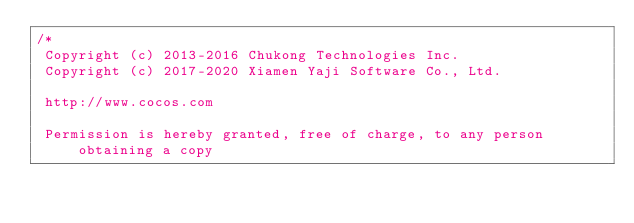Convert code to text. <code><loc_0><loc_0><loc_500><loc_500><_TypeScript_>/*
 Copyright (c) 2013-2016 Chukong Technologies Inc.
 Copyright (c) 2017-2020 Xiamen Yaji Software Co., Ltd.

 http://www.cocos.com

 Permission is hereby granted, free of charge, to any person obtaining a copy</code> 